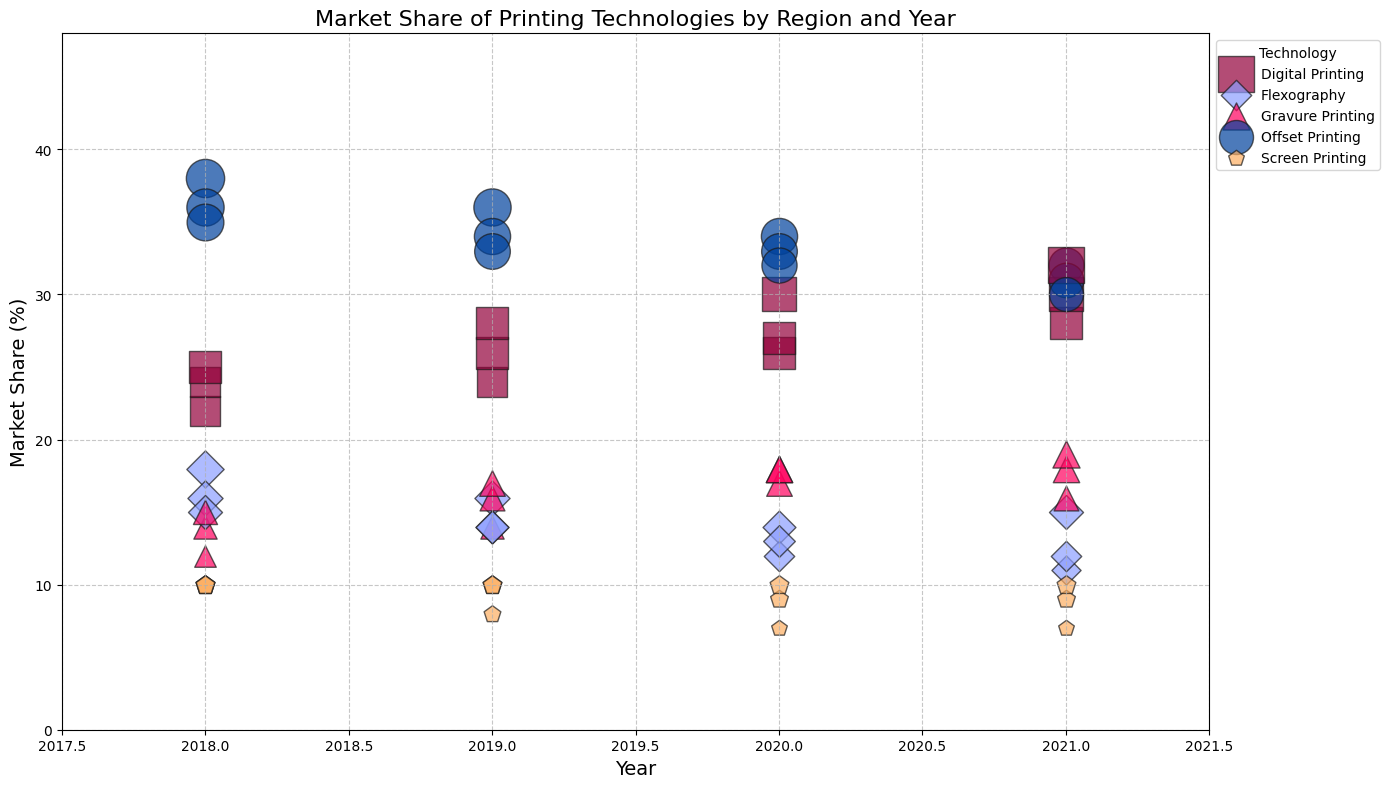Which region had the highest market share for Digital Printing in 2021? By looking for the largest bubble representing Digital Printing (typically a square shape) in 2021, you can identify the region.
Answer: North America How did the market share of Offset Printing change in North America from 2018 to 2021? Subtract the 2021 value from the 2018 value for Offset Printing in North America. Offset Printing in North America was 35% in 2018 and 30% in 2021. So, 35 - 30 = 5%.
Answer: Decreased by 5% Which printing technology had the largest increase in market share in Europe from 2018 to 2021? Identify each technology's market share in 2018 and 2021 in Europe and calculate the difference. Digital Printing increased from 24% in 2018 to 30% in 2021, which is the largest increase.
Answer: Digital Printing What was the average market share of Flexography in Asia from 2018 to 2021? Add market shares of Flexography in Asia for each year from 2018 to 2021 and divide by 4. (18 + 16 + 14 + 15) / 4 = 15.75%.
Answer: 15.75% Which region had the maximum market share for Screen Printing in 2020? Identify the largest bubble for Screen Printing (typically a pentagon shape) in 2020 across all regions. All regions had 10%, except North America with 7%.
Answer: Europe Did Gravure Printing's market share in North America grow or shrink from 2018 to 2021? Compare the market share value of Gravure Printing in North America between 2018 and 2021. It grew from 15% in 2018 to 19% in 2021.
Answer: Grew In 2020, did Digital Printing have a higher market share in Asia or Europe? Compare the size of the bubbles for Digital Printing in Asia and Europe for the year 2020. Both are 26%.
Answer: Same (26%) Which printing technology had the smallest bubble size in North America in 2021? Identify the smallest bubble (likely corresponding to the lowest market share) in North America in 2021. This is Screen Printing at 7%.
Answer: Screen Printing 